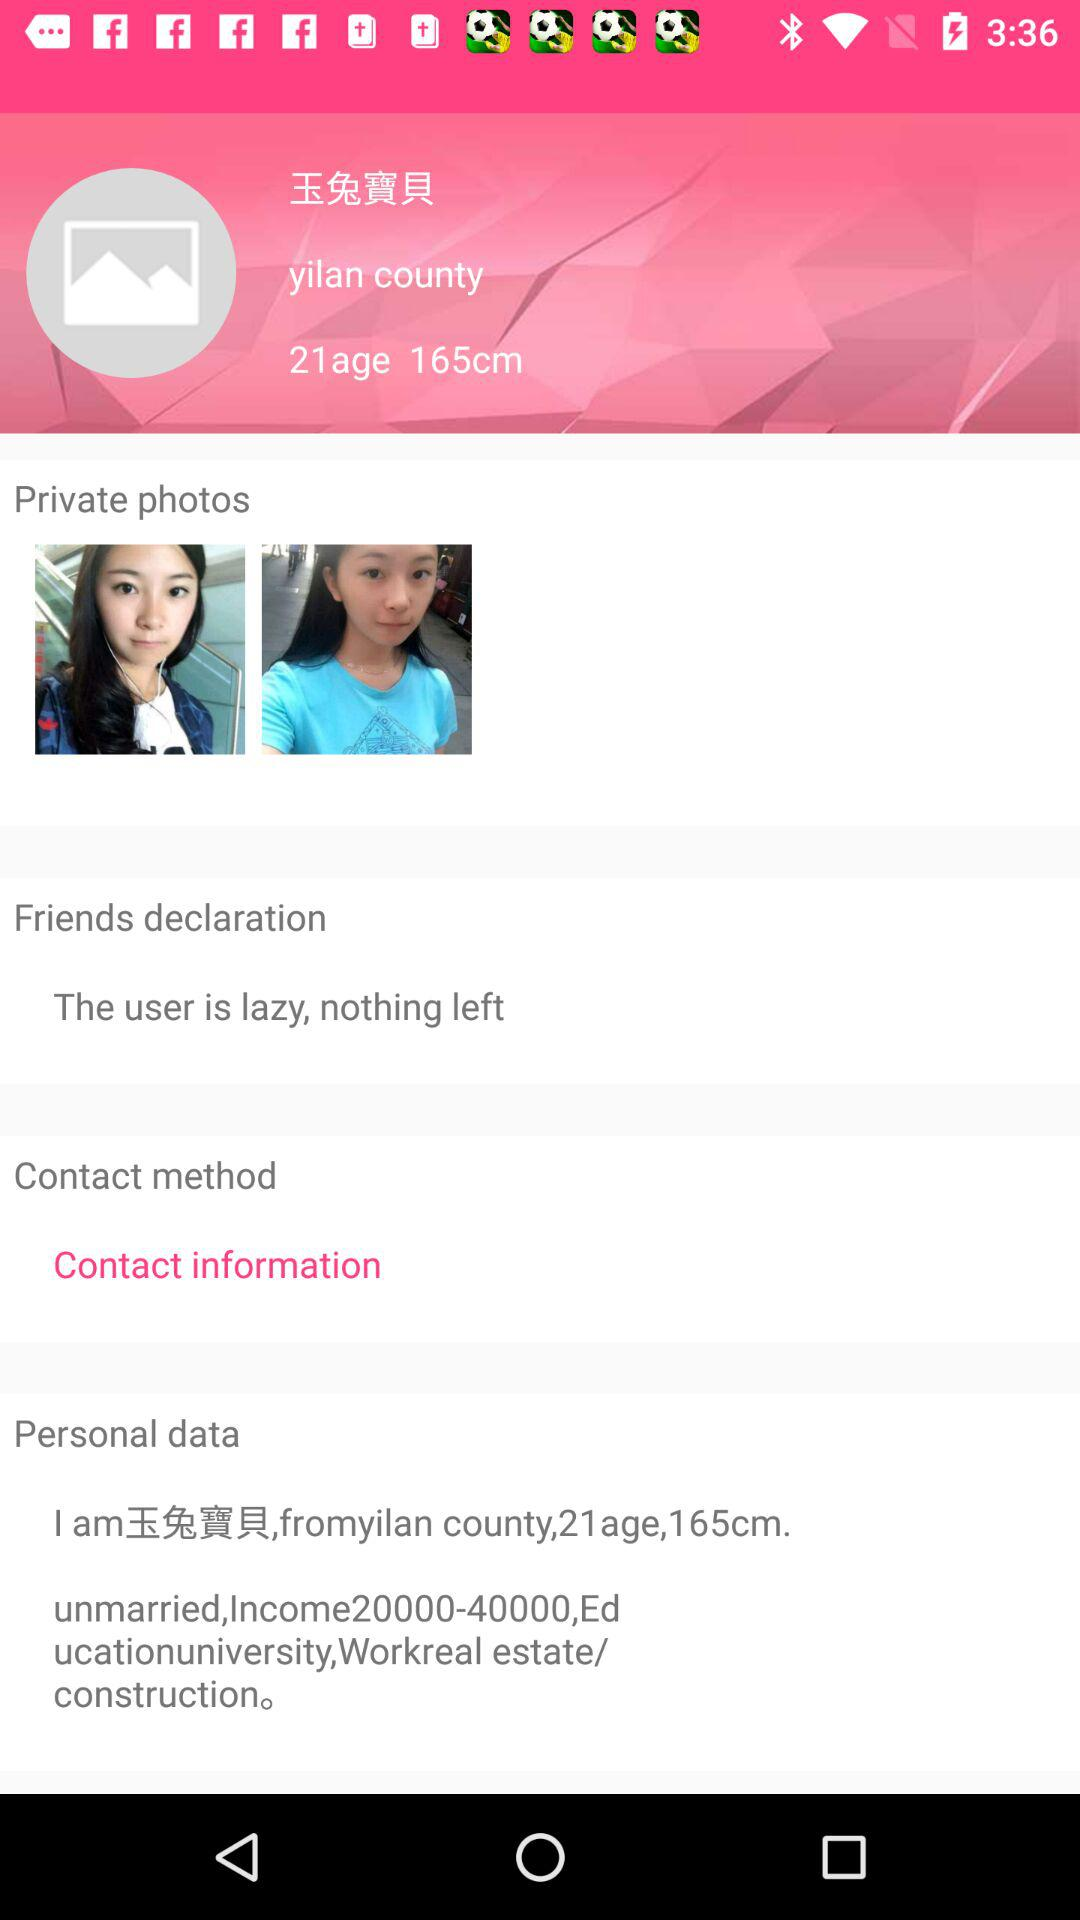What is the income range? The income range is 20000-40000,Ed. 